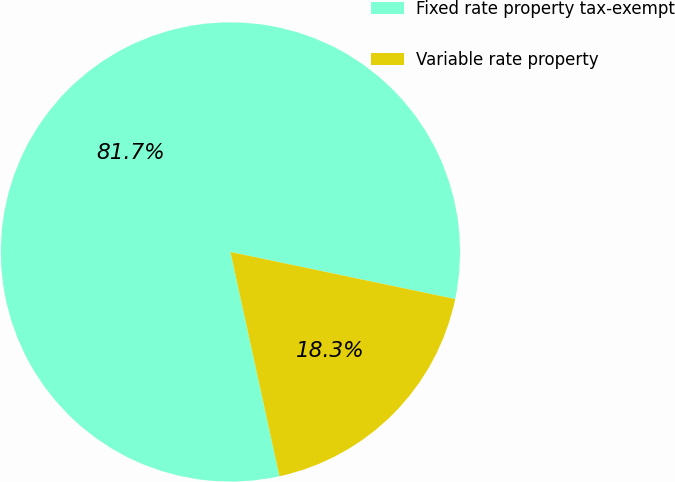<chart> <loc_0><loc_0><loc_500><loc_500><pie_chart><fcel>Fixed rate property tax-exempt<fcel>Variable rate property<nl><fcel>81.71%<fcel>18.29%<nl></chart> 